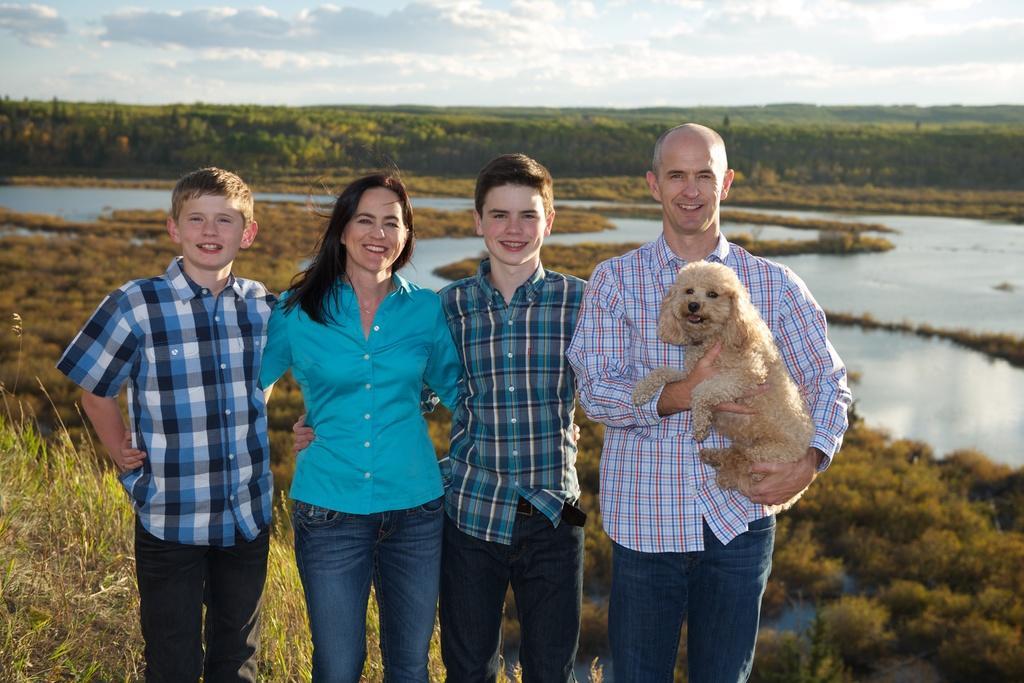How would you summarize this image in a sentence or two? In this image a boy standing and smiling , woman standing and smiling, boy standing and smiling, a man catching the dog standing and smiling and at the back ground there is a pool, plants , grass ,trees , sky covered with clouds. 